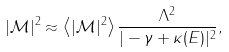Convert formula to latex. <formula><loc_0><loc_0><loc_500><loc_500>| \mathcal { M } | ^ { 2 } \approx \left \langle | \mathcal { M } | ^ { 2 } \right \rangle \frac { \Lambda ^ { 2 } } { | - \gamma + \kappa ( E ) | ^ { 2 } } ,</formula> 